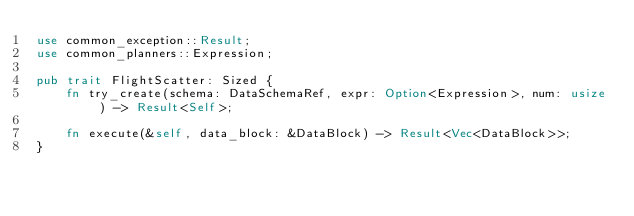<code> <loc_0><loc_0><loc_500><loc_500><_Rust_>use common_exception::Result;
use common_planners::Expression;

pub trait FlightScatter: Sized {
    fn try_create(schema: DataSchemaRef, expr: Option<Expression>, num: usize) -> Result<Self>;

    fn execute(&self, data_block: &DataBlock) -> Result<Vec<DataBlock>>;
}
</code> 